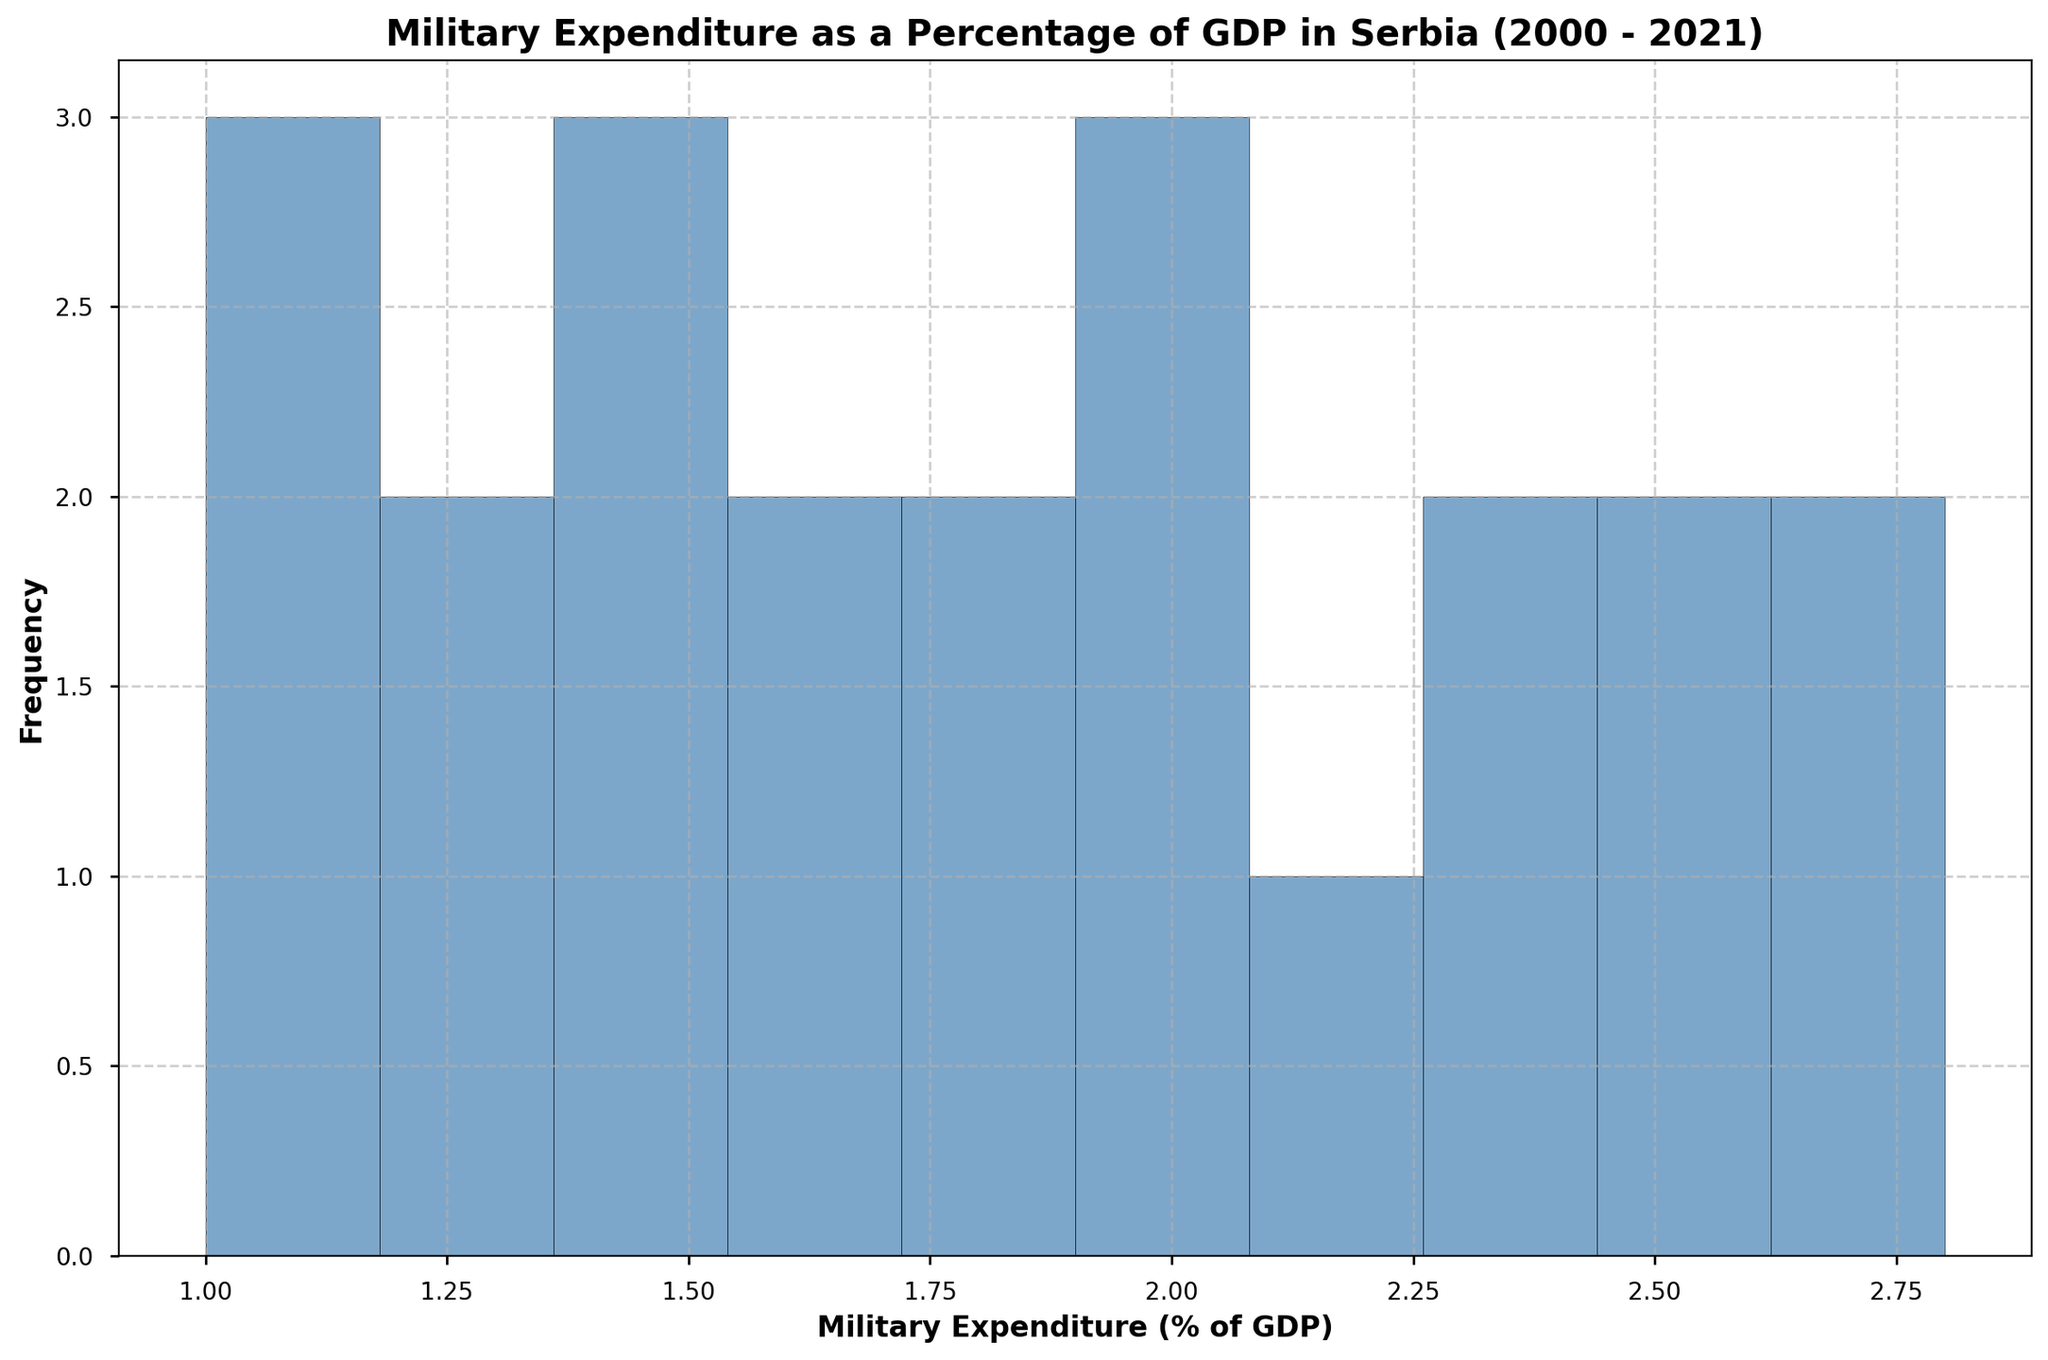What decade shows the highest frequency of military expenditure as a percentage of GDP between 1.1% and 1.8%? To answer this, observe the bins on the histogram for the interval 1.1% to 1.8% and count the frequency of bars within that range. The decade with most bars in this interval is the 2010s.
Answer: 2010s What is the mode of the military expenditure as a percentage of GDP based on the histogram? The mode is the value that appears most frequently. From the histogram, identify the tallest bar which represents the highest frequency.
Answer: 1.00% How does the frequency of military expenditure percentages of 2.0% and above compare to those below 2%? Check the bars of the histogram for values 2.0% and above and compare their total frequency to those bars below 2%. The lower percentages have a higher frequency.
Answer: Below 2.0% has a higher frequency Around which percentage range does Serbia's military expenditure seem to decrease post-2000, based on the histogram? Looking at the overall pattern of the histogram, identify where the frequencies start to shift from higher to lower values, indicating a decrease.
Answer: Around 2.0% What is the approximate range for the middle half (interquartile range) of military expenditure percentages in the histogram? To find the interquartile range, look for the range where the middle 50% of the data lies, which is generally around the central bins with most frequencies. Estimate the values based on the histogram.
Answer: 1.0% - 1.8% Is there any significant change in the frequency of military expenditure percentages over time? Compare the number of bars and their heights across different value ranges over years. Significant changes would appear as shifts in the histogram distribution.
Answer: Yes, expenditure decreased over the first decade but slightly increased again in recent years Which period has more consistent military expenditure percentages, early 2000s or late 2010s? Check the spread and height of bars for each period's typical range. Consistency would show as a narrower and more focused range.
Answer: Late 2010s What military expenditure percentage appears to be the least frequent, based on the histogram? Identify the smallest bars which indicate the least frequencies and note their ranges.
Answer: 2.8% How does the military expenditure as a percentage of GDP in the last few years compare with the early 2000s? Compare the distribution and heights of bars representing the early and latest years. The first few years show higher values, while the later years indicate a return to higher values but less frequently as before.
Answer: Early 2000s were higher but recent years have increased again 